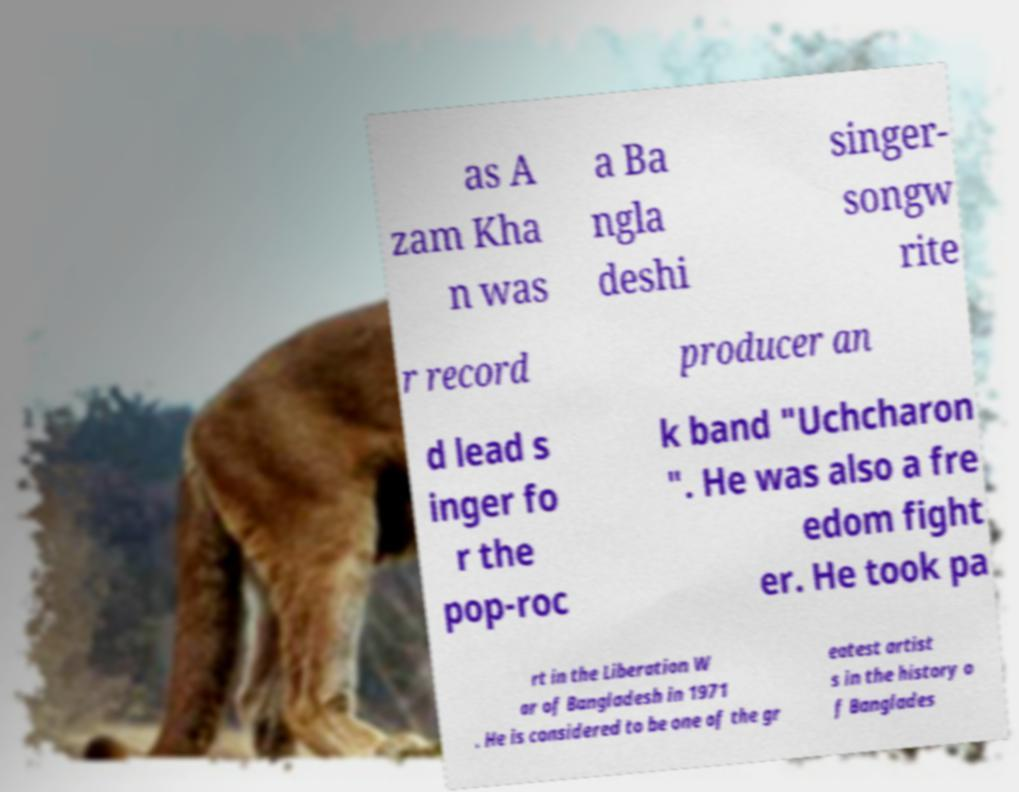Can you accurately transcribe the text from the provided image for me? as A zam Kha n was a Ba ngla deshi singer- songw rite r record producer an d lead s inger fo r the pop-roc k band "Uchcharon ". He was also a fre edom fight er. He took pa rt in the Liberation W ar of Bangladesh in 1971 . He is considered to be one of the gr eatest artist s in the history o f Banglades 